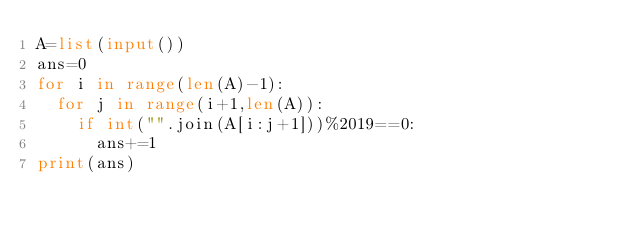Convert code to text. <code><loc_0><loc_0><loc_500><loc_500><_Python_>A=list(input())
ans=0
for i in range(len(A)-1):
  for j in range(i+1,len(A)):
    if int("".join(A[i:j+1]))%2019==0:
      ans+=1
print(ans)</code> 